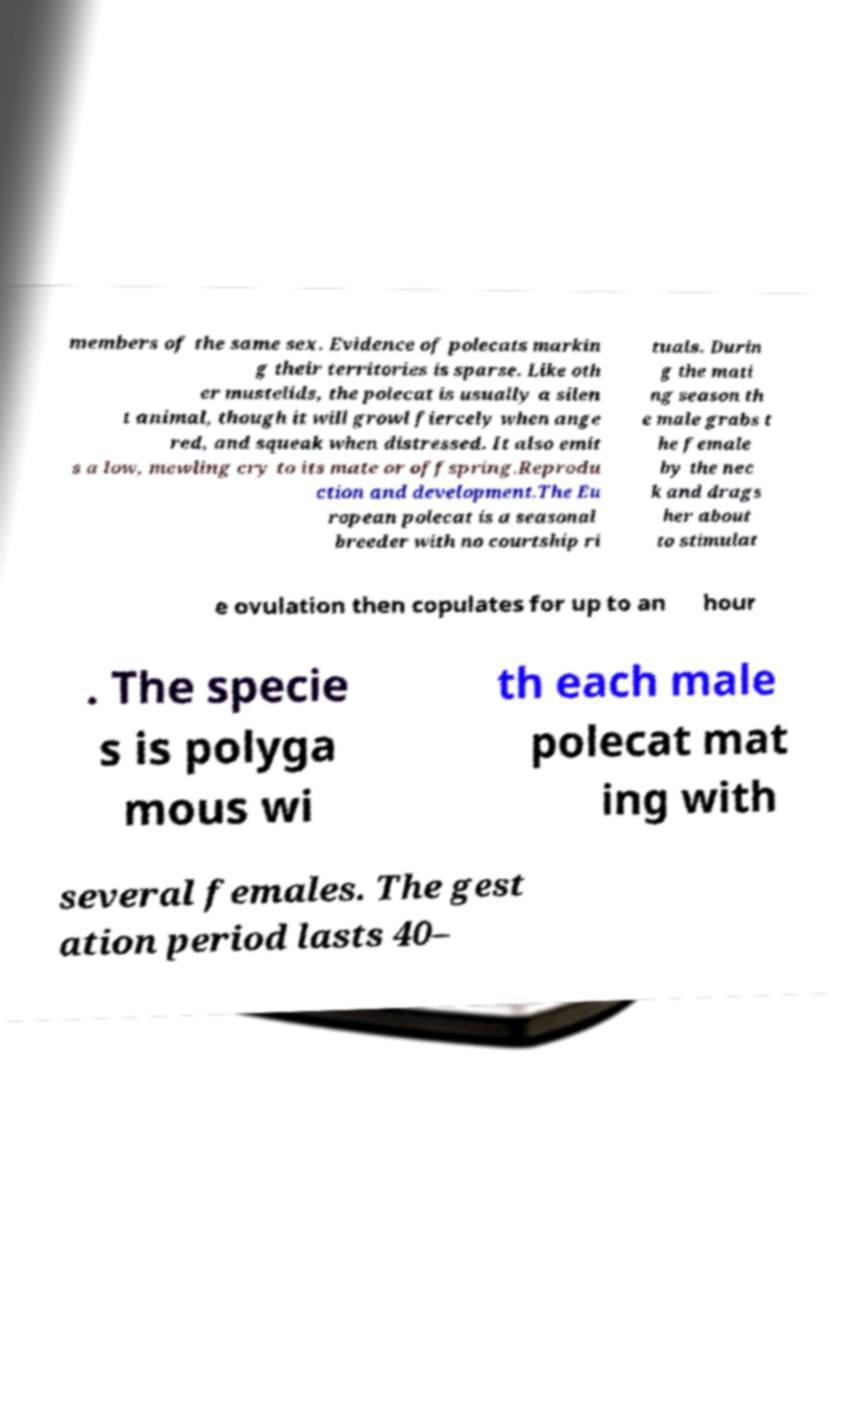Could you assist in decoding the text presented in this image and type it out clearly? members of the same sex. Evidence of polecats markin g their territories is sparse. Like oth er mustelids, the polecat is usually a silen t animal, though it will growl fiercely when ange red, and squeak when distressed. It also emit s a low, mewling cry to its mate or offspring.Reprodu ction and development.The Eu ropean polecat is a seasonal breeder with no courtship ri tuals. Durin g the mati ng season th e male grabs t he female by the nec k and drags her about to stimulat e ovulation then copulates for up to an hour . The specie s is polyga mous wi th each male polecat mat ing with several females. The gest ation period lasts 40– 